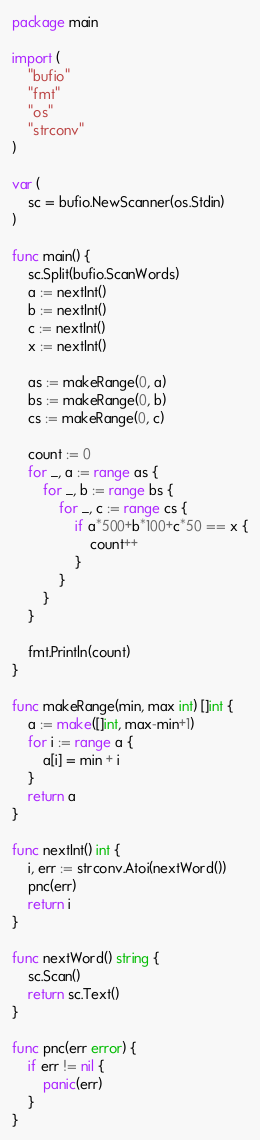Convert code to text. <code><loc_0><loc_0><loc_500><loc_500><_Go_>package main

import (
	"bufio"
	"fmt"
	"os"
	"strconv"
)

var (
	sc = bufio.NewScanner(os.Stdin)
)

func main() {
	sc.Split(bufio.ScanWords)
	a := nextInt()
	b := nextInt()
	c := nextInt()
	x := nextInt()

	as := makeRange(0, a)
	bs := makeRange(0, b)
	cs := makeRange(0, c)

	count := 0
	for _, a := range as {
		for _, b := range bs {
			for _, c := range cs {
				if a*500+b*100+c*50 == x {
					count++
				}
			}
		}
	}

	fmt.Println(count)
}

func makeRange(min, max int) []int {
	a := make([]int, max-min+1)
	for i := range a {
		a[i] = min + i
	}
	return a
}

func nextInt() int {
	i, err := strconv.Atoi(nextWord())
	pnc(err)
	return i
}

func nextWord() string {
	sc.Scan()
	return sc.Text()
}

func pnc(err error) {
	if err != nil {
		panic(err)
	}
}
</code> 